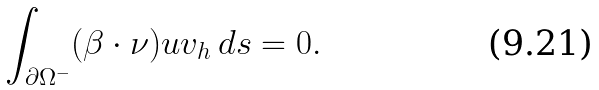Convert formula to latex. <formula><loc_0><loc_0><loc_500><loc_500>\int _ { \partial \Omega ^ { - } } ( \beta \cdot \nu ) u v _ { h } \, d s = 0 .</formula> 